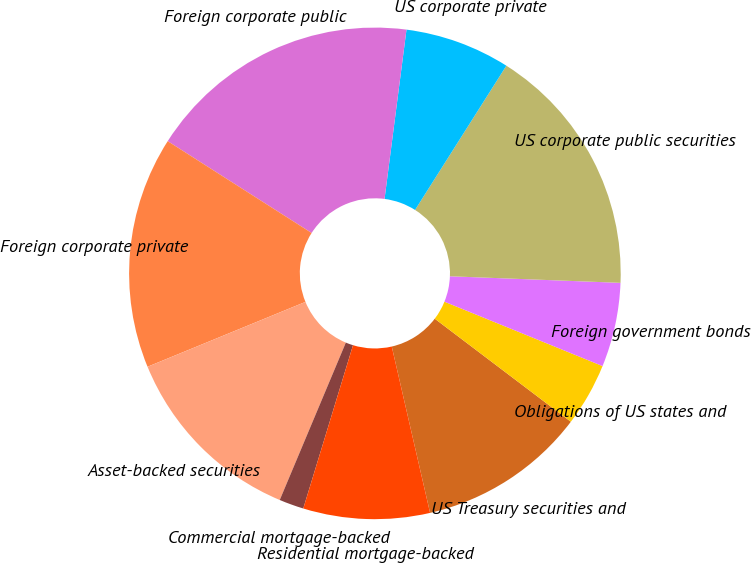<chart> <loc_0><loc_0><loc_500><loc_500><pie_chart><fcel>US Treasury securities and<fcel>Obligations of US states and<fcel>Foreign government bonds<fcel>US corporate public securities<fcel>US corporate private<fcel>Foreign corporate public<fcel>Foreign corporate private<fcel>Asset-backed securities<fcel>Commercial mortgage-backed<fcel>Residential mortgage-backed<nl><fcel>11.08%<fcel>4.16%<fcel>5.54%<fcel>16.63%<fcel>6.93%<fcel>18.01%<fcel>15.24%<fcel>12.47%<fcel>1.62%<fcel>8.31%<nl></chart> 